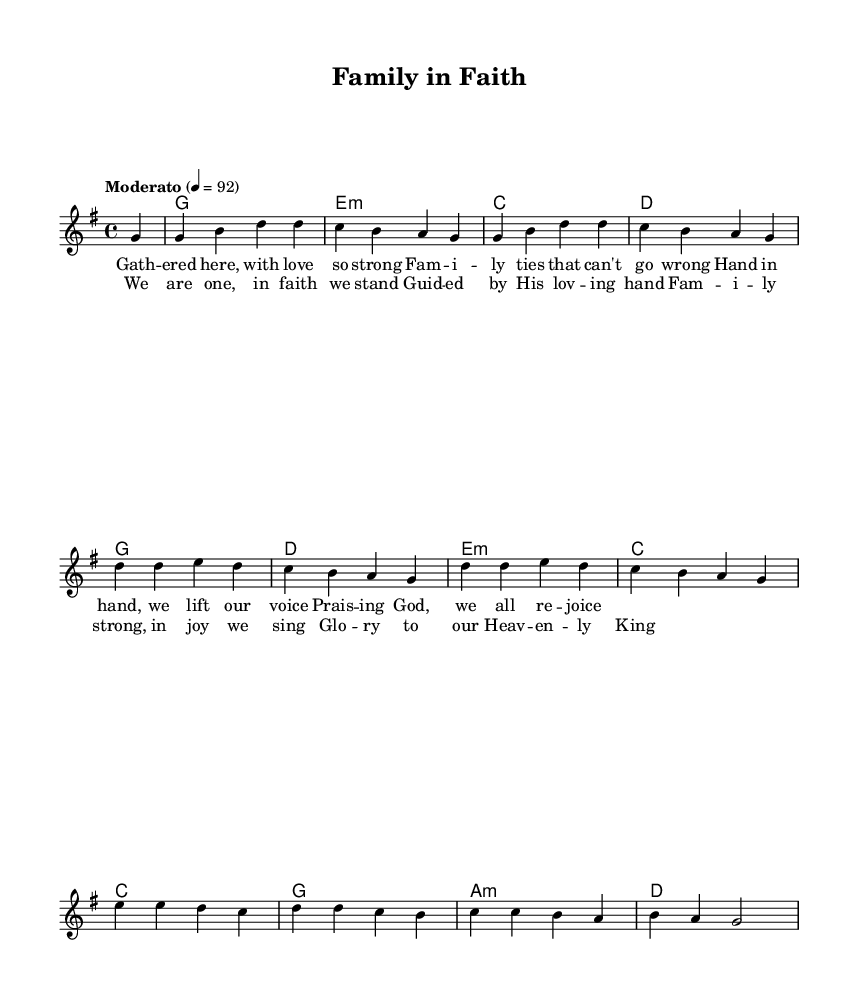What is the key signature of this music? The key signature is G major, which has one sharp (F#). You can determine this from the global field where \key g \major is specified.
Answer: G major What is the time signature of this music? The time signature is 4/4, which indicates there are four beats in each measure. This is visible in the global field where \time 4/4 is written.
Answer: 4/4 What is the tempo marking for this piece? The tempo marking is Moderato, and it is set at a quarter note equals 92 beats per minute. This information is also found in the global field following the \tempo directive.
Answer: Moderato How many measures are in the melody? The melody includes eight measures. You can count the vertical lines (bar lines) in the melody section, which separate the measures.
Answer: 8 What is the text of the chorus section? The text of the chorus section begins with "We are one, in faith we stand," as indicated under the \lyricmode for the chorus. This section of the lyrics is separate from the verse and is printed underneath the melody corresponding to the chorus.
Answer: We are one, in faith we stand What instruments or voices are indicated for this piece? The piece indicates a melody line and accompanying chords. You can identify this from the score structure where the \new Voice and \new ChordNames specify the sections.
Answer: Voice and Chords What type of song is this? This song is a gospel-inspired praise and worship song, evident from the themes of family and faith expressed in the lyrics and music.
Answer: Gospel-inspired 